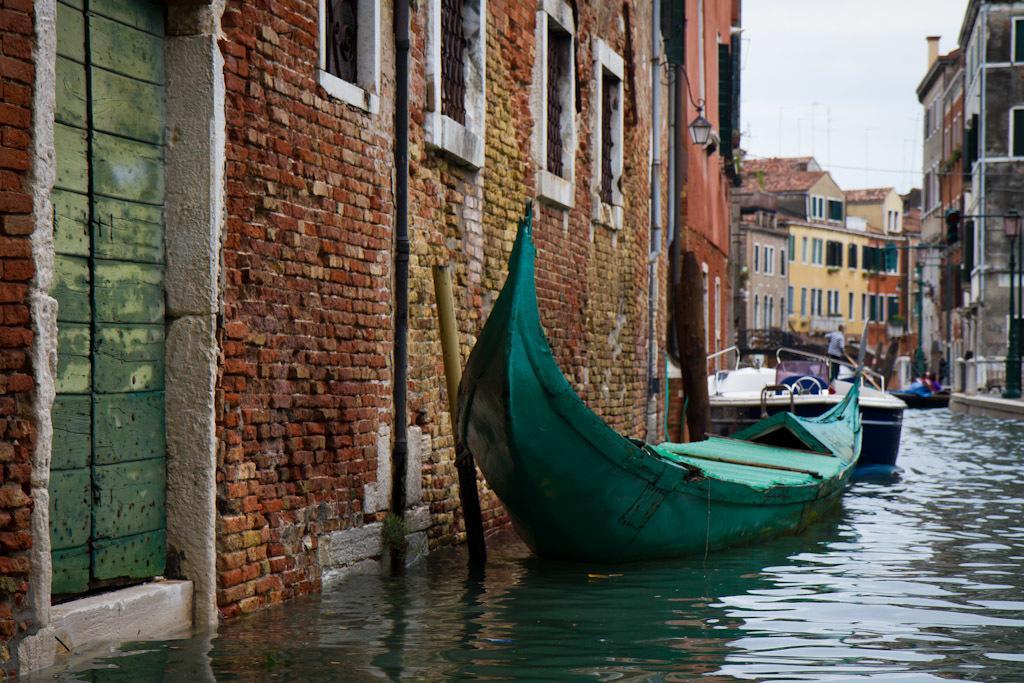Please provide a concise description of this image. In the foreground of this image, there are boats on the water. On the left, there are buildings and a light. In the background, there are buildings and the sky. 